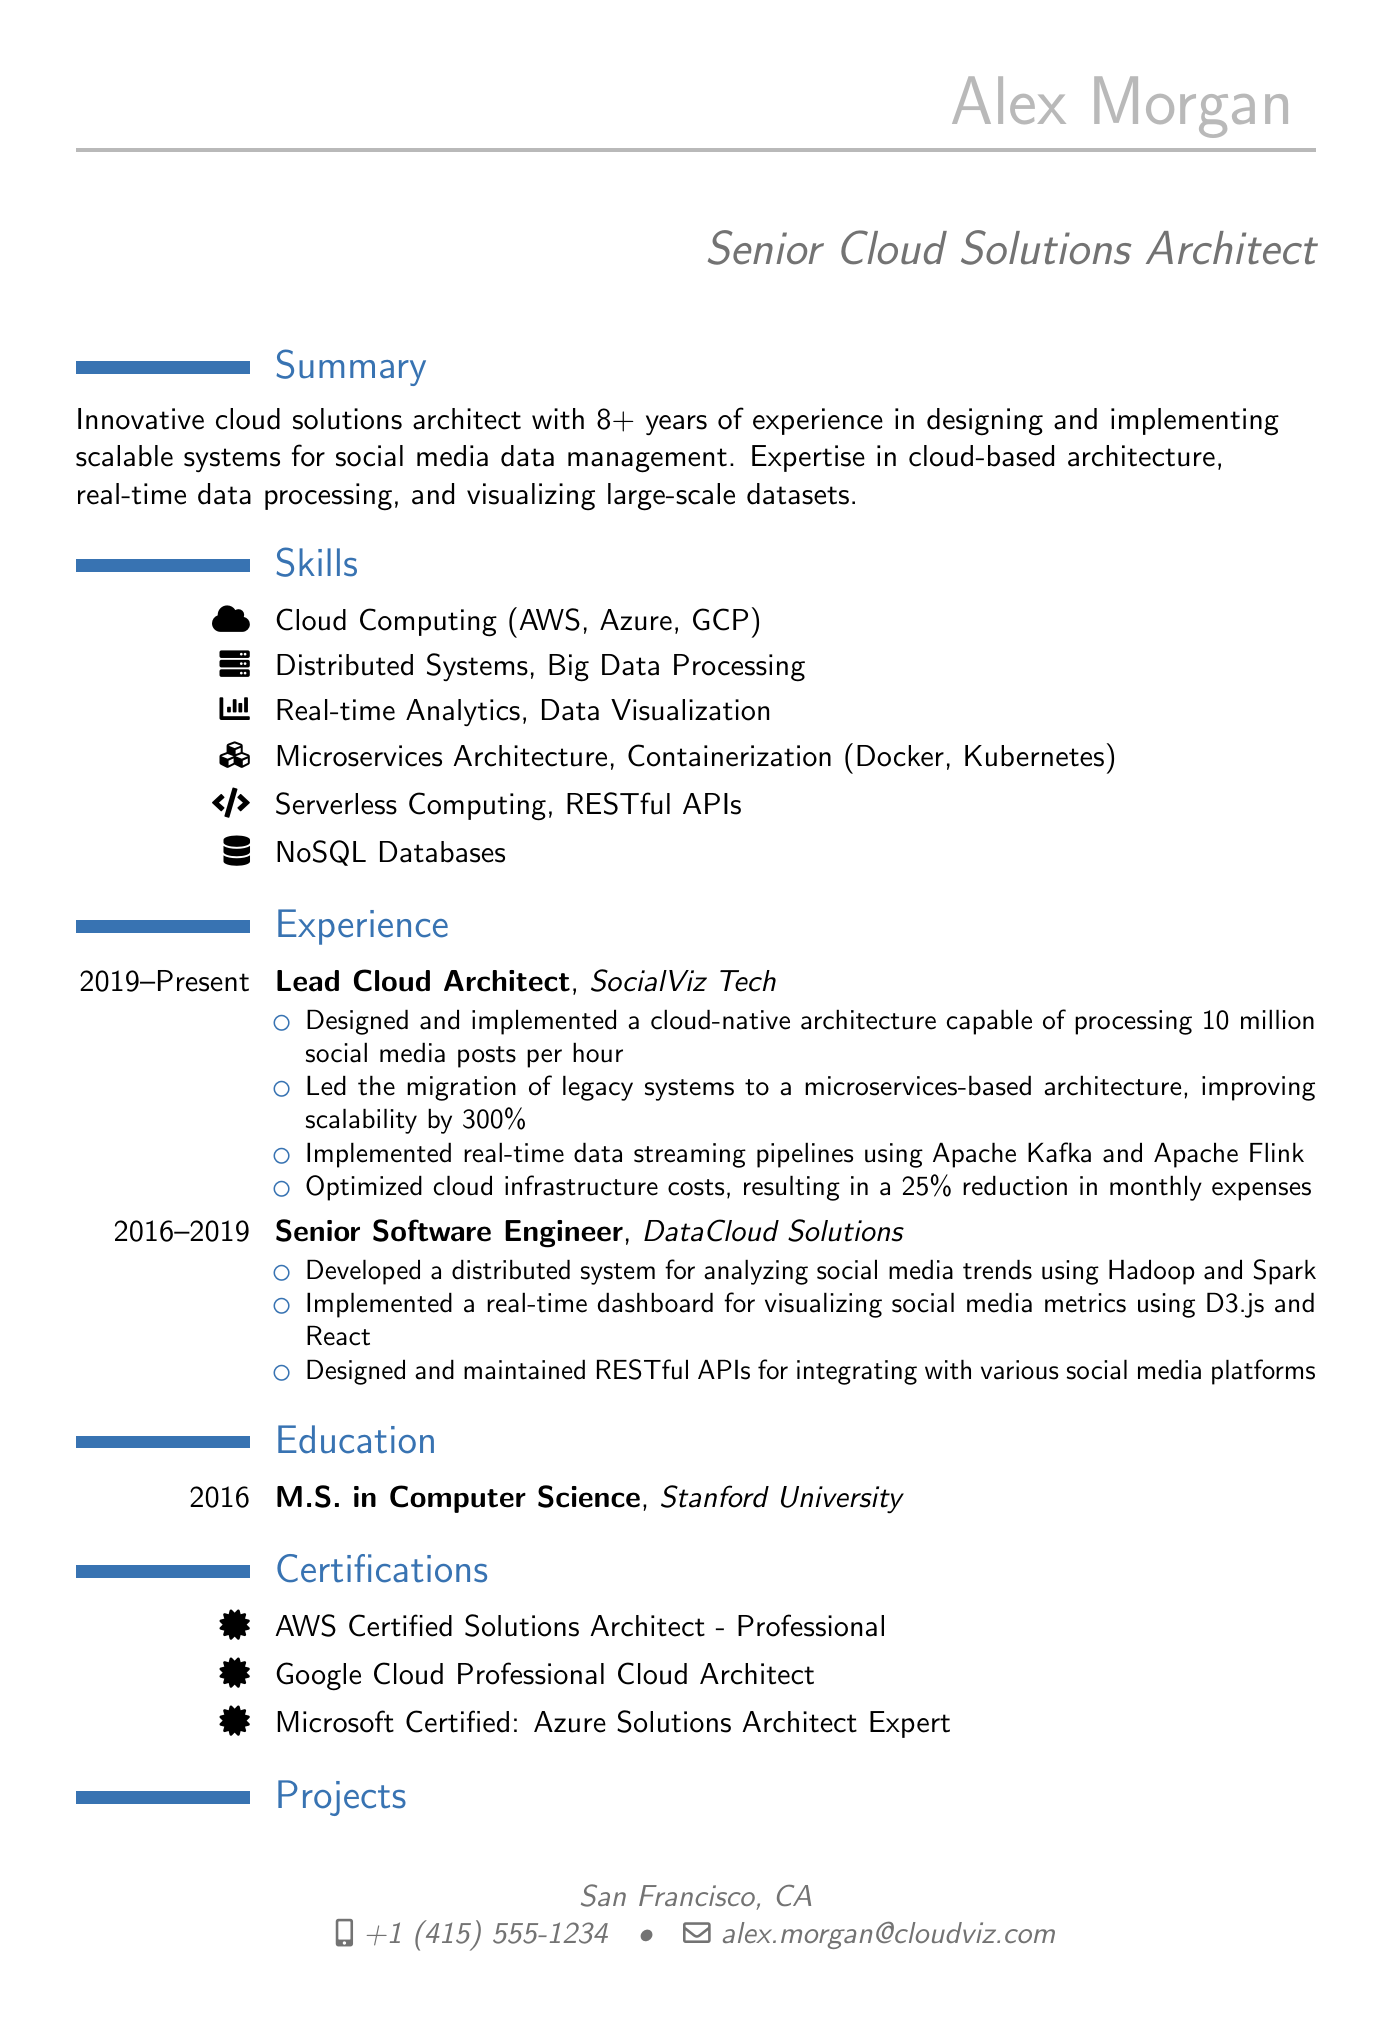what is the title of Alex Morgan? The title is the professional position held by Alex Morgan, which is listed in the document.
Answer: Senior Cloud Solutions Architect how many years of experience does Alex Morgan have? The summary states the number of years of experience that Alex Morgan has in the field.
Answer: 8+ years what is the degree obtained by Alex Morgan? The education section specifies the degree earned by Alex Morgan and the institution attended.
Answer: M.S. in Computer Science which company did Alex Morgan work for as a Lead Cloud Architect? The experience section lists the title and corresponding company where Alex Morgan held that position.
Answer: SocialViz Tech how much improvement in scalability was achieved by migrating to a microservices-based architecture? The responsibilities for the Lead Cloud Architect position mention the percentage improvement in scalability achieved.
Answer: 300% what is one of the certifications Alex Morgan holds? The certifications section lists various qualifications, any of which can answer this question.
Answer: AWS Certified Solutions Architect - Professional what project did Alex Morgan create related to social media? The projects section describes the project that Alex Morgan developed, indicating its focus area.
Answer: SocialPulse how many social media posts per hour could the architecture handle? The responsibilities of the Lead Cloud Architect state the processing capability of the architecture.
Answer: 10 million what technologies are mentioned under skills for cloud computing? The skills section lists the technologies that Alex Morgan is proficient in concerning cloud computing.
Answer: AWS, Azure, GCP 